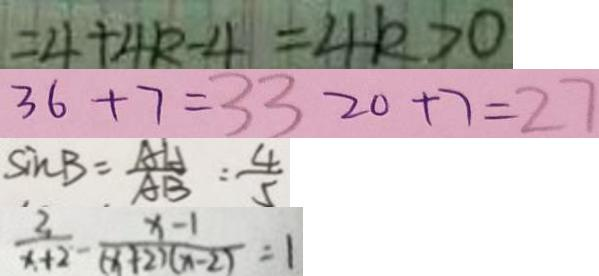<formula> <loc_0><loc_0><loc_500><loc_500>= 4 + 4 k - 4 = 4 k > 0 
 3 6 + 7 = 3 3 2 0 + 7 = 2 7 
 \sin B = \frac { A H } { A B } = \frac { 4 } { 5 } 
 \frac { 2 } { x + 2 } - \frac { x - 1 } { ( x + 2 ) ( x - 2 ) } = 1</formula> 